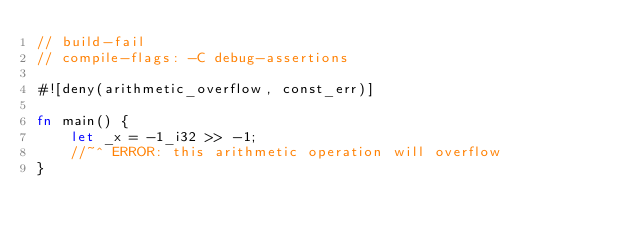<code> <loc_0><loc_0><loc_500><loc_500><_Rust_>// build-fail
// compile-flags: -C debug-assertions

#![deny(arithmetic_overflow, const_err)]

fn main() {
    let _x = -1_i32 >> -1;
    //~^ ERROR: this arithmetic operation will overflow
}
</code> 